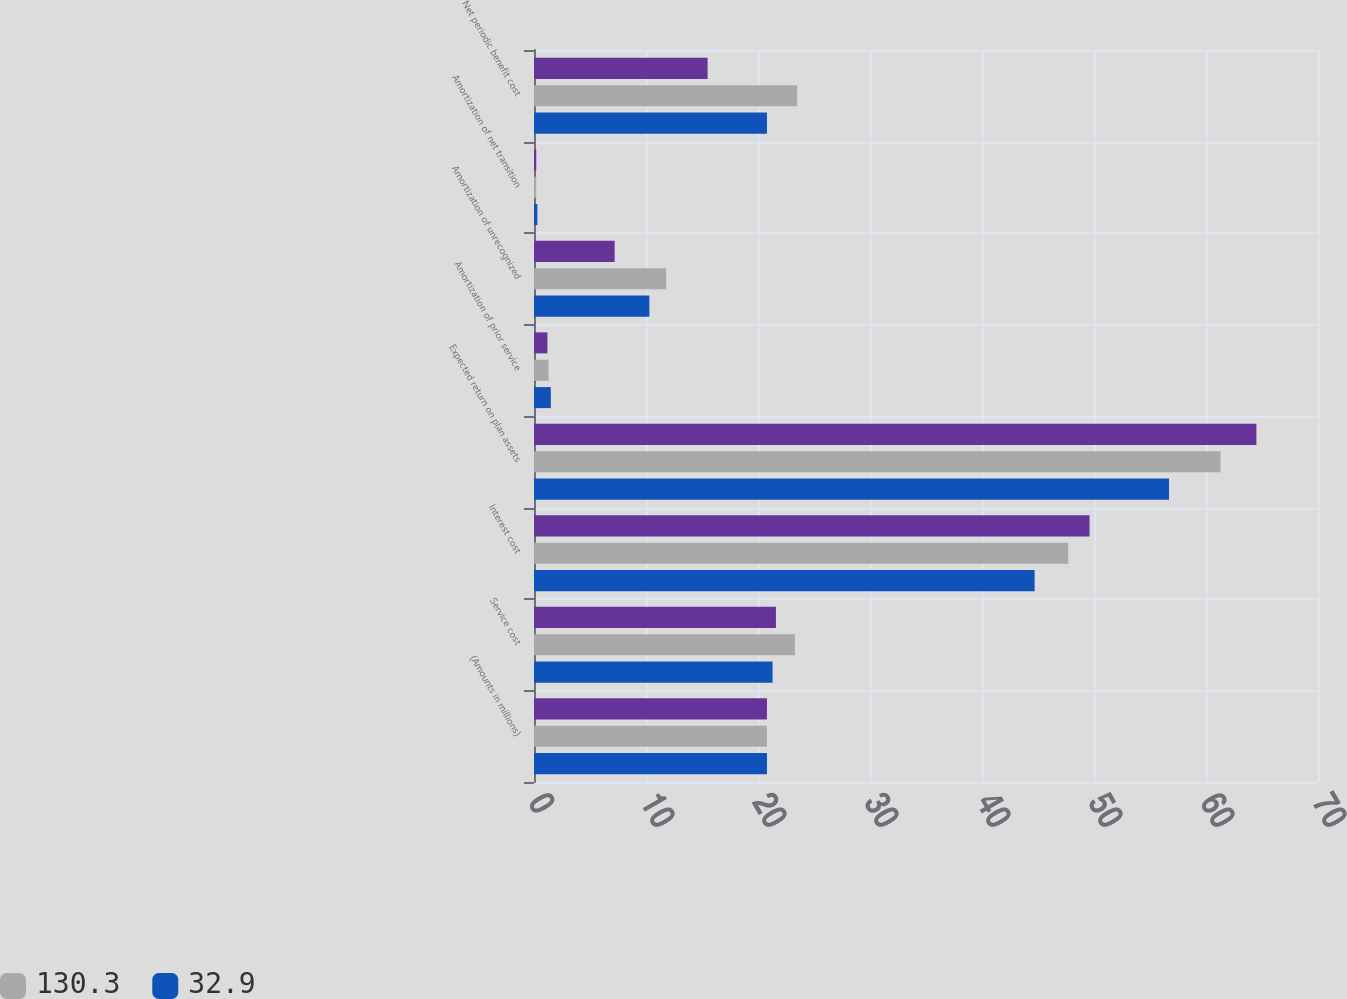Convert chart to OTSL. <chart><loc_0><loc_0><loc_500><loc_500><stacked_bar_chart><ecel><fcel>(Amounts in millions)<fcel>Service cost<fcel>Interest cost<fcel>Expected return on plan assets<fcel>Amortization of prior service<fcel>Amortization of unrecognized<fcel>Amortization of net transition<fcel>Net periodic benefit cost<nl><fcel>nan<fcel>20.8<fcel>21.6<fcel>49.6<fcel>64.5<fcel>1.2<fcel>7.2<fcel>0.2<fcel>15.5<nl><fcel>130.3<fcel>20.8<fcel>23.3<fcel>47.7<fcel>61.3<fcel>1.3<fcel>11.8<fcel>0.2<fcel>23.5<nl><fcel>32.9<fcel>20.8<fcel>21.3<fcel>44.7<fcel>56.7<fcel>1.5<fcel>10.3<fcel>0.3<fcel>20.8<nl></chart> 